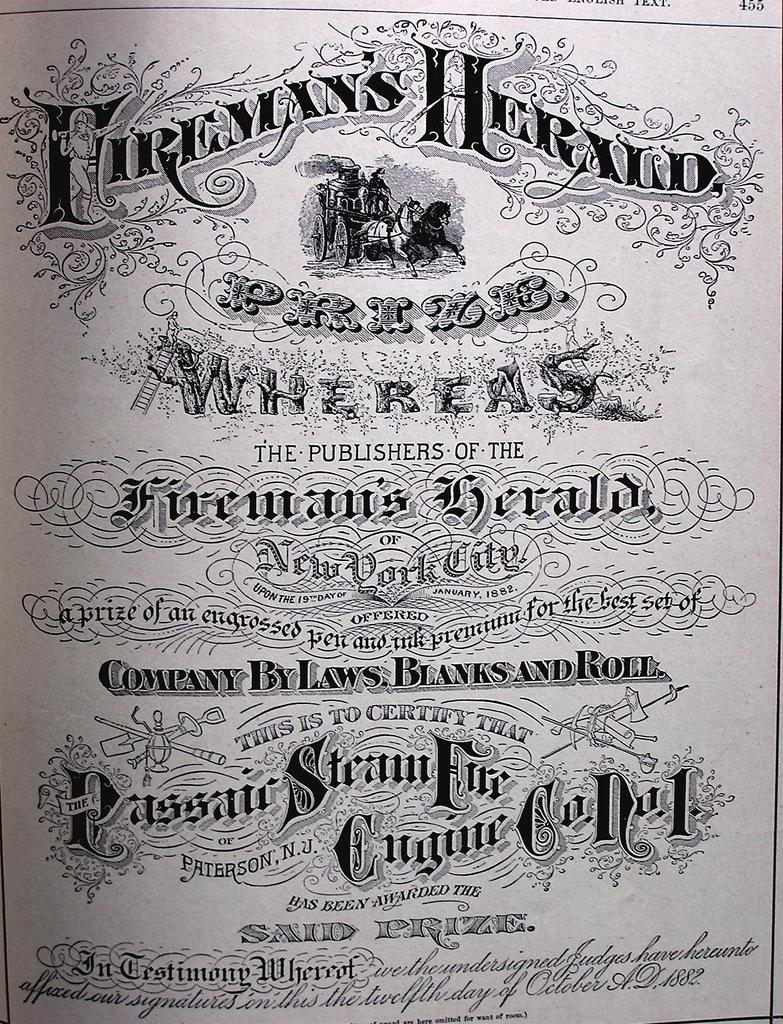Provide a one-sentence caption for the provided image. Fireman's Herald prize sign that is company by laws, blanks, and roll. 